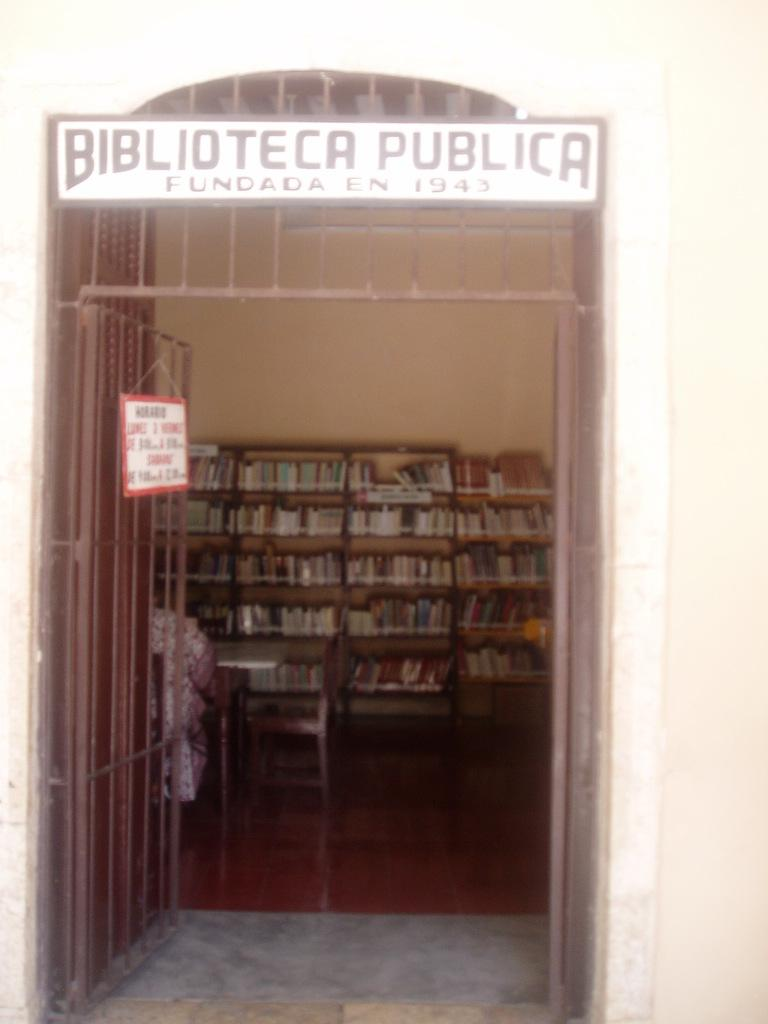<image>
Relay a brief, clear account of the picture shown. An open gate with a sign that says BIBLIOTECA PUBLICA. 